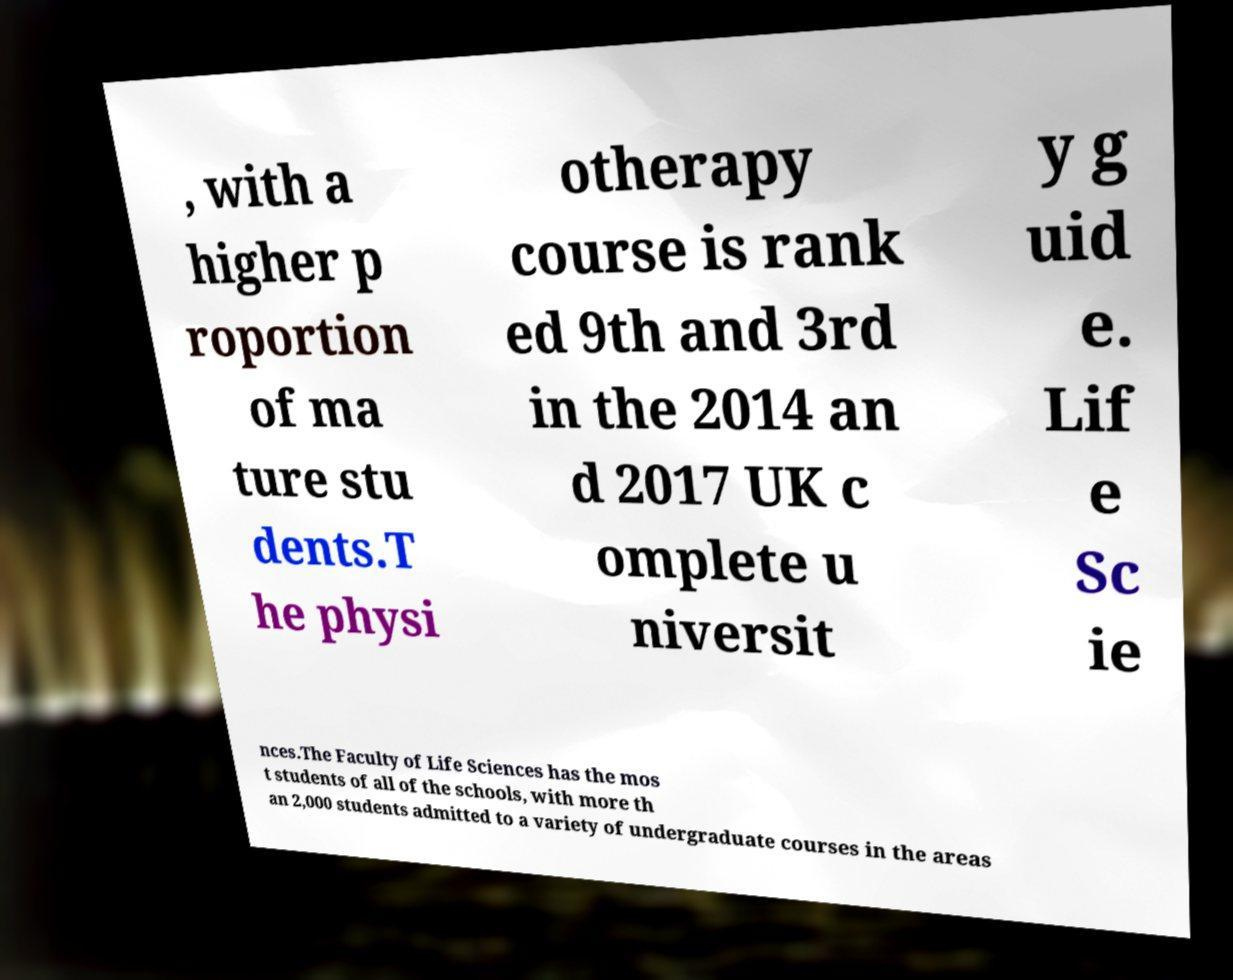Could you extract and type out the text from this image? , with a higher p roportion of ma ture stu dents.T he physi otherapy course is rank ed 9th and 3rd in the 2014 an d 2017 UK c omplete u niversit y g uid e. Lif e Sc ie nces.The Faculty of Life Sciences has the mos t students of all of the schools, with more th an 2,000 students admitted to a variety of undergraduate courses in the areas 